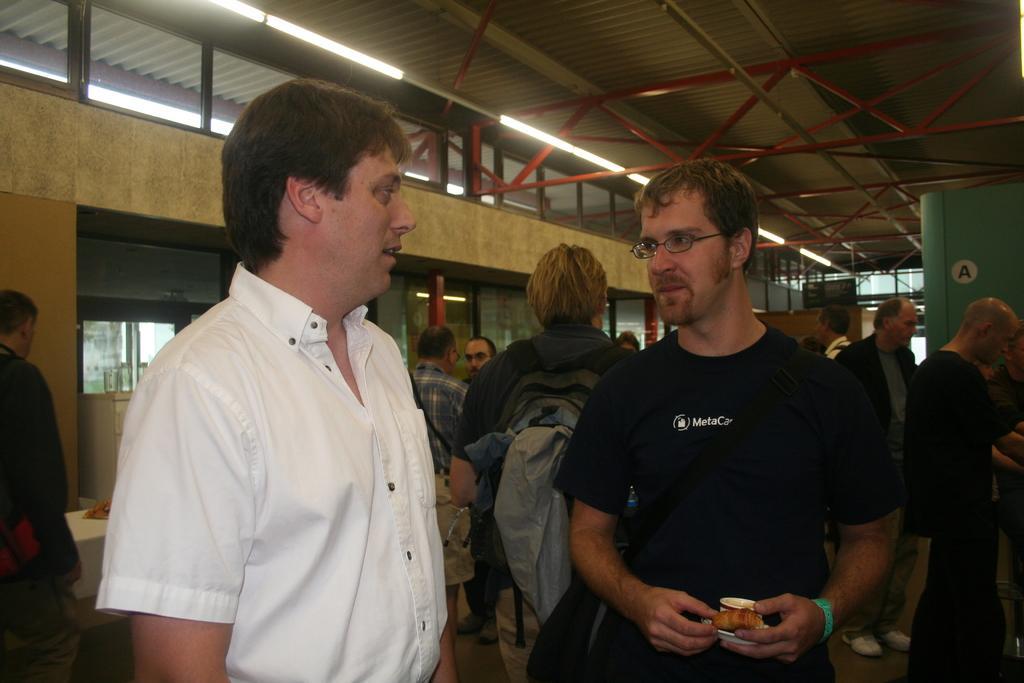Describe this image in one or two sentences. In this picture we can see a man wearing a spectacle and a bag. This man is holding a few things in his hands. We can see a few people, lights, glass objects, rods and other objects. 